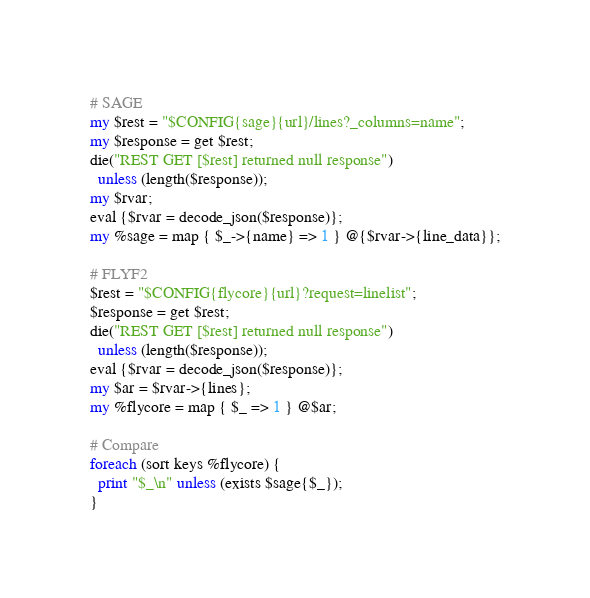<code> <loc_0><loc_0><loc_500><loc_500><_Perl_>
# SAGE
my $rest = "$CONFIG{sage}{url}/lines?_columns=name";
my $response = get $rest;
die("REST GET [$rest] returned null response")
  unless (length($response));
my $rvar;
eval {$rvar = decode_json($response)};
my %sage = map { $_->{name} => 1 } @{$rvar->{line_data}};

# FLYF2
$rest = "$CONFIG{flycore}{url}?request=linelist";
$response = get $rest;
die("REST GET [$rest] returned null response")
  unless (length($response));
eval {$rvar = decode_json($response)};
my $ar = $rvar->{lines};
my %flycore = map { $_ => 1 } @$ar;

# Compare
foreach (sort keys %flycore) {
  print "$_\n" unless (exists $sage{$_});
}
</code> 